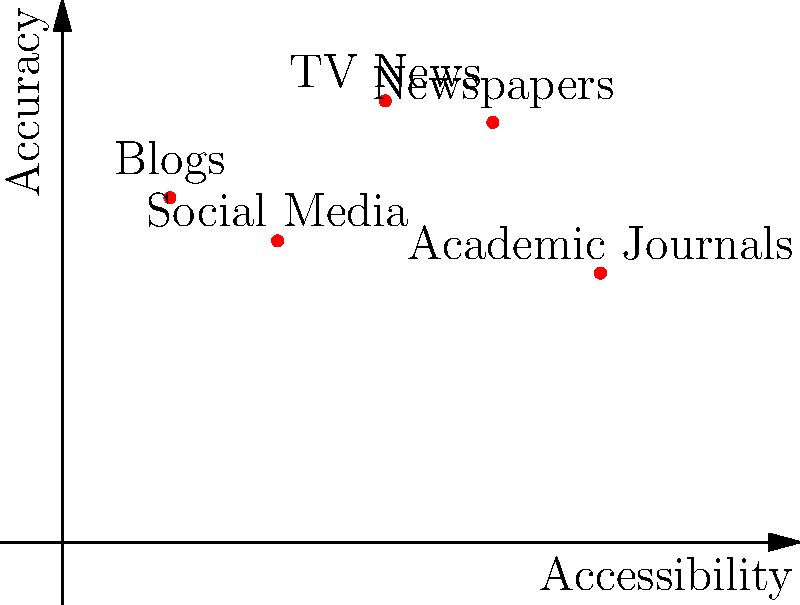Based on the scatter plot comparing different news sources, which source appears to be the most accurate while still being relatively accessible? To answer this question, we need to analyze the scatter plot, considering both the accessibility (x-axis) and accuracy (y-axis) of each news source:

1. Blogs: (1, 3.2) - High accessibility, moderate accuracy
2. Social Media: (2, 2.8) - High accessibility, lower accuracy
3. TV News: (3, 4.1) - Moderate accessibility, high accuracy
4. Newspapers: (4, 3.9) - Lower accessibility, high accuracy
5. Academic Journals: (5, 2.5) - Low accessibility, lower accuracy

We're looking for a source that balances high accuracy with reasonable accessibility. TV News has the highest accuracy (4.1) while still maintaining moderate accessibility (3 on the x-axis). Newspapers have similar accuracy but lower accessibility.

While Academic Journals might be expected to have high accuracy, the data shows otherwise, possibly due to their specialized nature and potential lag in reporting current events.

Blogs and Social Media, despite their high accessibility, have lower accuracy compared to TV News and Newspapers.
Answer: TV News 